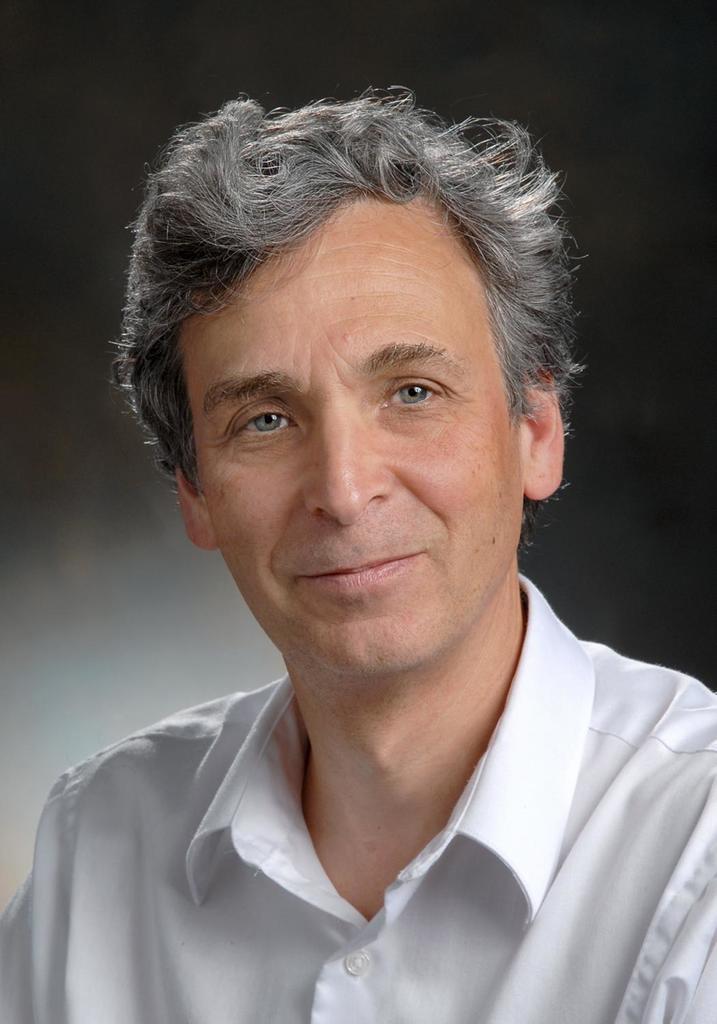How would you summarize this image in a sentence or two? In this image in the front there is a person smiling and the background is blurry. 